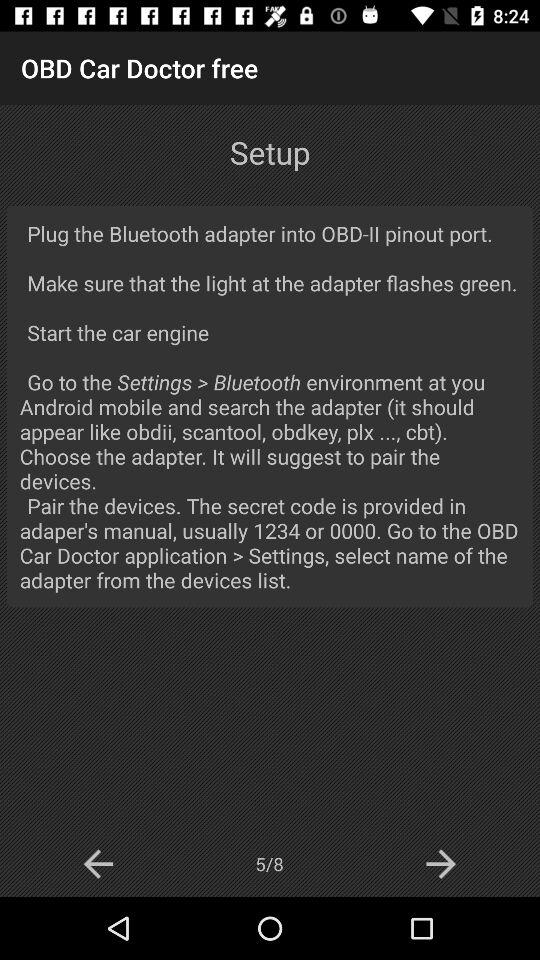How many pages in total are there? There are total 8 pages. 